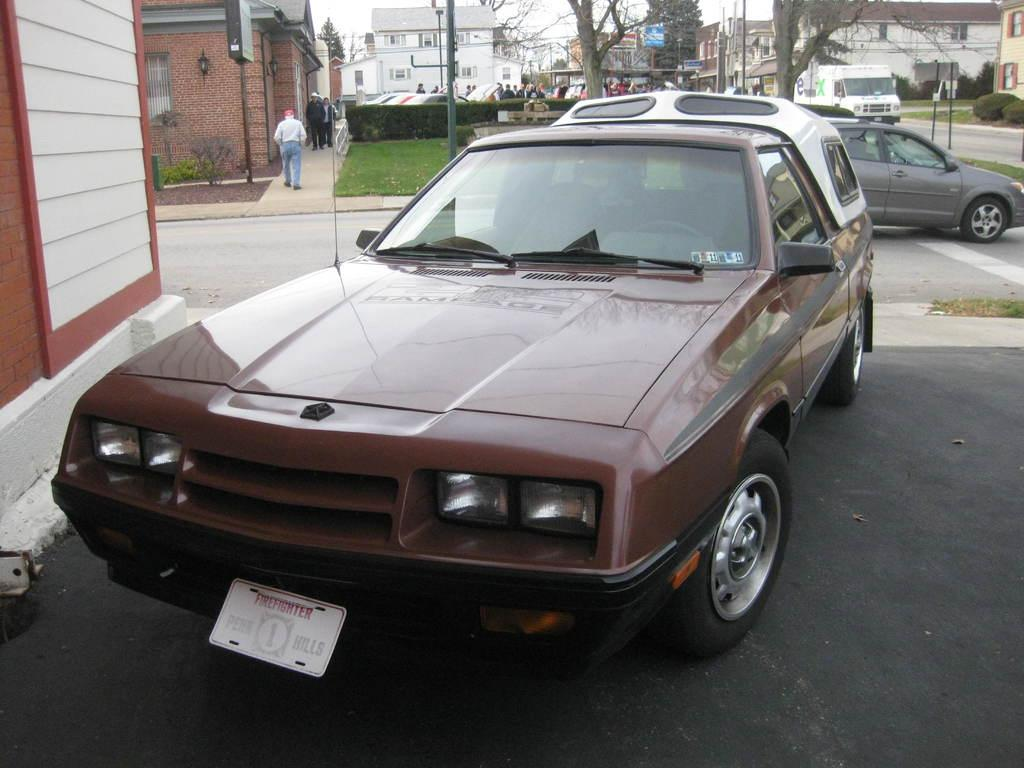What types of objects can be seen in the image? There are vehicles, poles, boards, plants, buildings, and trees in the image. Can you describe the people in the image? There is a group of people standing in the image. What might the poles and boards be used for? The poles and boards could be part of a structure or signage. What type of education is being taught in the image? There is no indication of any educational activity in the image. How many trucks are visible in the image? There is no mention of trucks in the image; the vehicles present are not specified. 